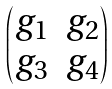<formula> <loc_0><loc_0><loc_500><loc_500>\begin{pmatrix} g _ { 1 } & g _ { 2 } \\ g _ { 3 } & g _ { 4 } \end{pmatrix}</formula> 